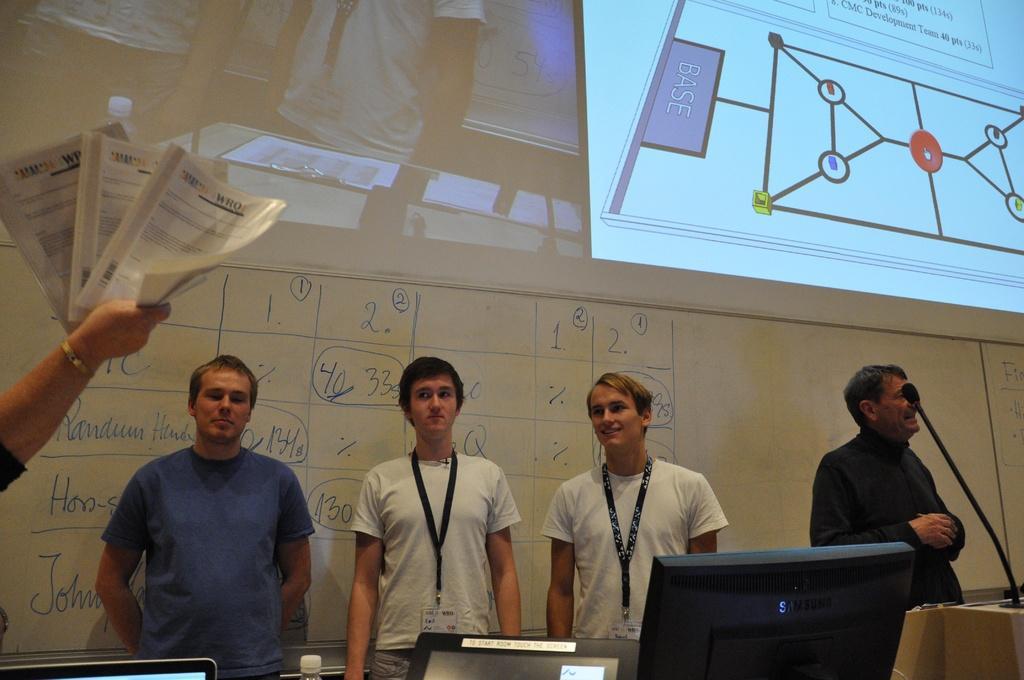In one or two sentences, can you explain what this image depicts? In this image we can see four persons are standing. One is wearing blue color t-shirt and the other two are wearing white color t-shirt and wearing ID cards in there neck. The fourth person is wearing black color shirt. Behind them one big screen and board is present. Bottom of the image mic and monitors are there. Left side of the image one person is holdings files in hand. 